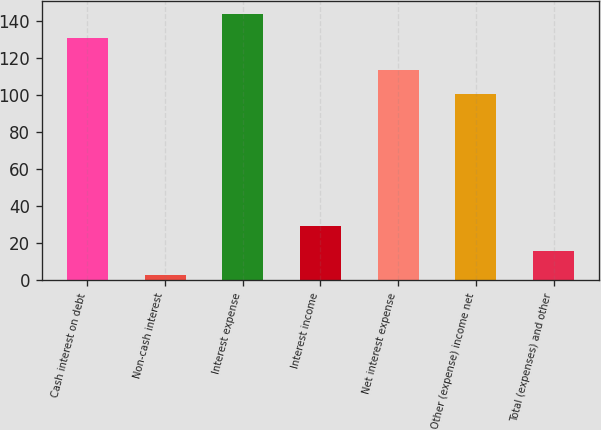Convert chart. <chart><loc_0><loc_0><loc_500><loc_500><bar_chart><fcel>Cash interest on debt<fcel>Non-cash interest<fcel>Interest expense<fcel>Interest income<fcel>Net interest expense<fcel>Other (expense) income net<fcel>Total (expenses) and other<nl><fcel>130.6<fcel>2.9<fcel>143.66<fcel>29.5<fcel>113.56<fcel>100.5<fcel>15.96<nl></chart> 